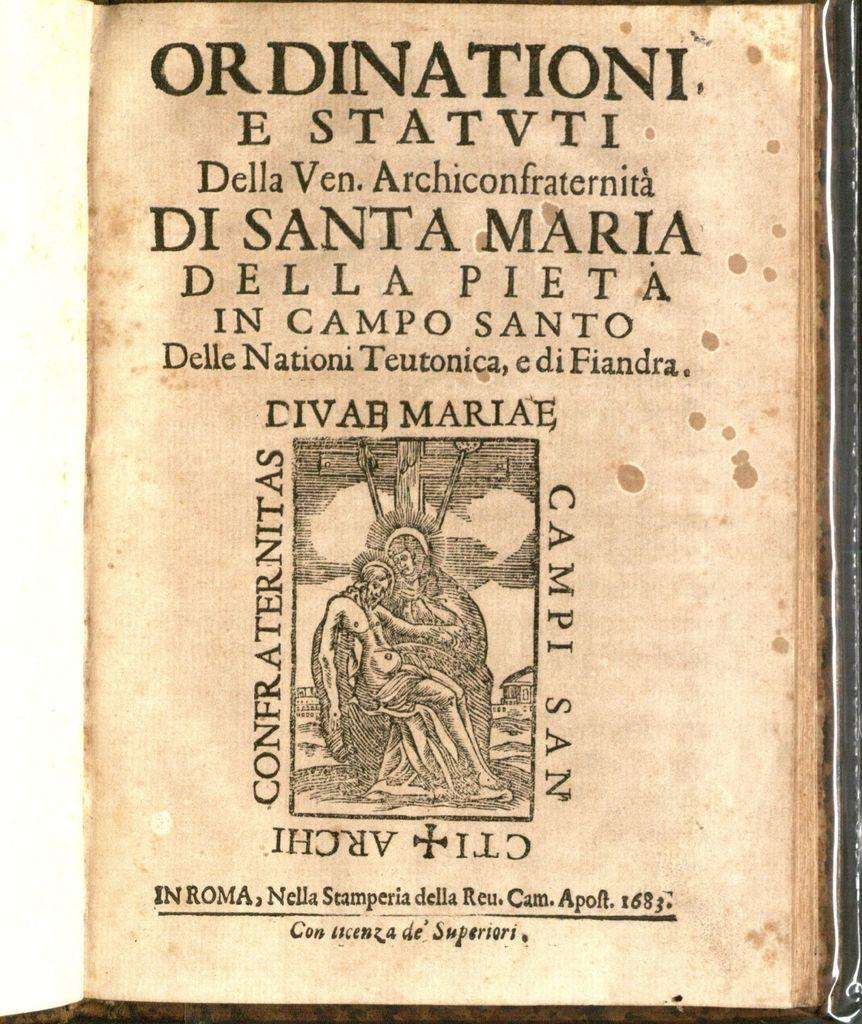Provide a one-sentence caption for the provided image. A page of a book that is titiled Ordinationi E Statvti. 